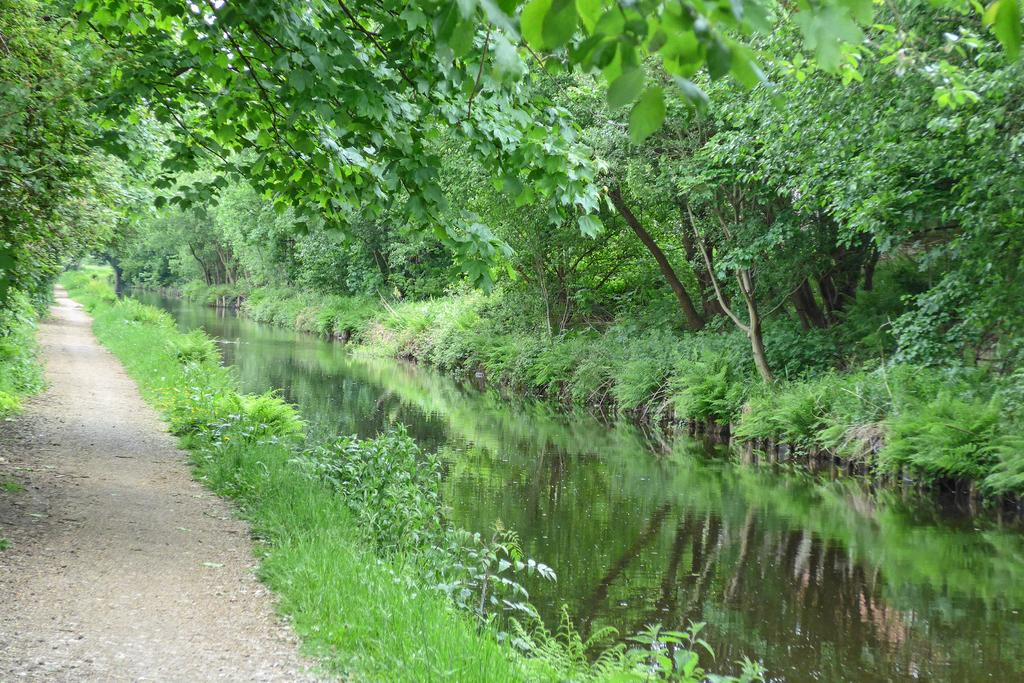What is the main feature in the center of the image? There is a river in the center of the image. What can be seen on either side of the river? There are trees, plants, and grass on either side of the river. Is there any indication of a path or road in the image? Yes, there is a lane at the bottom left of the image. How many cows are pushing a calculator across the river in the image? There are no cows or calculators present in the image. 